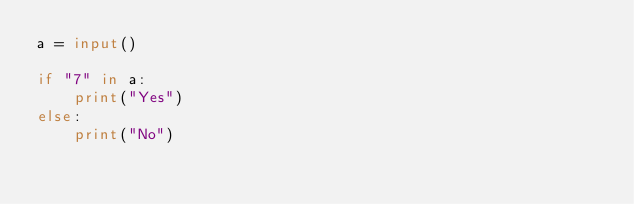<code> <loc_0><loc_0><loc_500><loc_500><_Python_>a = input()

if "7" in a:
    print("Yes")
else:
    print("No")</code> 